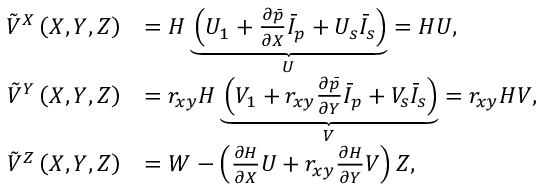<formula> <loc_0><loc_0><loc_500><loc_500>\begin{array} { r l } { \tilde { V } ^ { X } \left ( X , Y , Z \right ) } & { = H \underbrace { \left ( U _ { 1 } + \frac { \partial \ B a r { p } } { \partial X } \ B a r { I } _ { p } + U _ { s } \ B a r { I } _ { s } \right ) } _ { U } = H U , } \\ { \tilde { V } ^ { Y } \left ( X , Y , Z \right ) } & { = r _ { x y } H \underbrace { \left ( V _ { 1 } + r _ { x y } \frac { \partial \ B a r { p } } { \partial Y } \ B a r { I } _ { p } + V _ { s } \ B a r { I } _ { s } \right ) } _ { V } = r _ { x y } H V , } \\ { \tilde { V } ^ { Z } \left ( X , Y , Z \right ) } & { = W - \left ( \frac { \partial H } { \partial X } U + r _ { x y } \frac { \partial H } { \partial Y } V \right ) Z , } \end{array}</formula> 